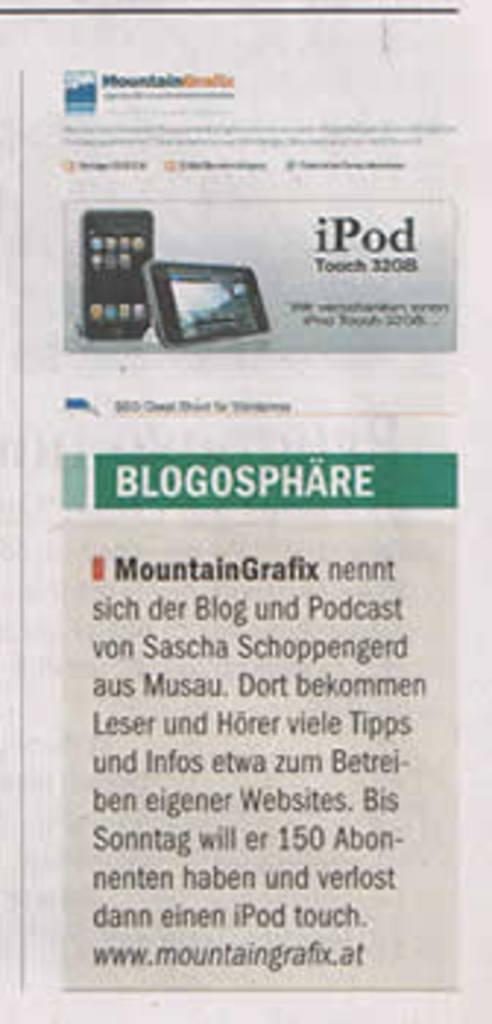<image>
Relay a brief, clear account of the picture shown. an article page with the title 'blogosphare' on it 